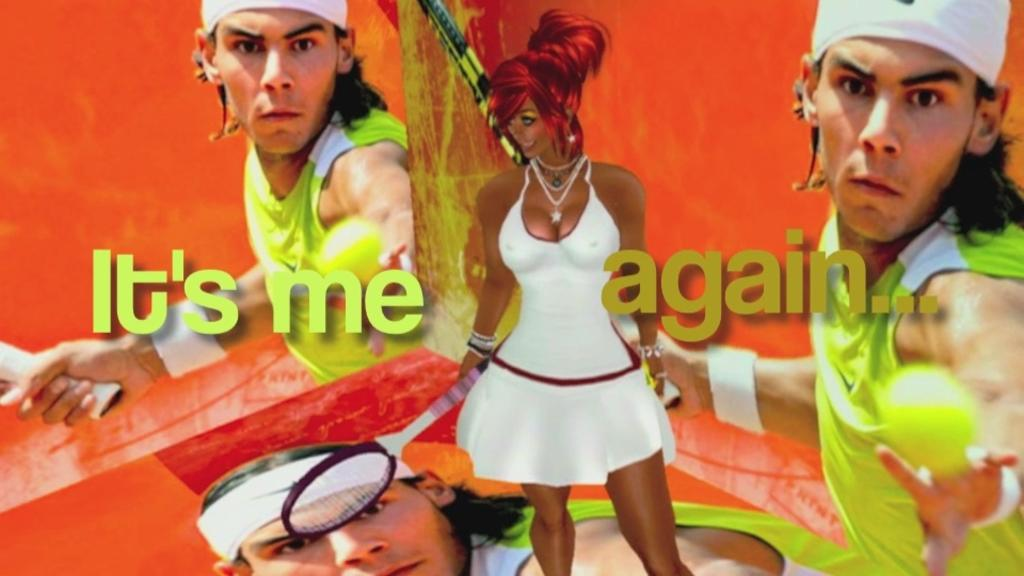What is depicted on the poster in the image? There is a poster of a man in the image, and he is holding a tennis racket. What type of picture is also present in the image? There is holding a racket in the animated picture. What color are the eggs in the image? There are no eggs present in the image. Who is the coach of the man in the poster? The provided facts do not mention a coach, so it cannot be determined from the image. 